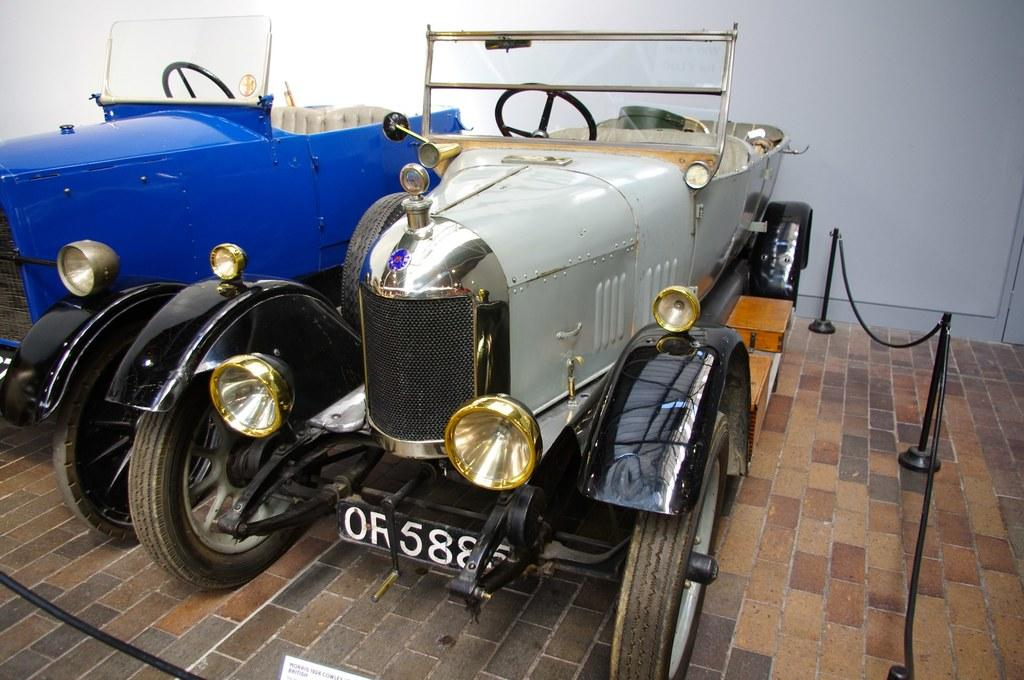What types of objects are present in the image? There are vehicles in the image. What is located behind the vehicles? There is a wall behind the vehicles in the image. Where can fencing be found in the image? Fencing can be found in the bottom right corner of the image. Can you see a cave in the image? There is no cave present in the image. 